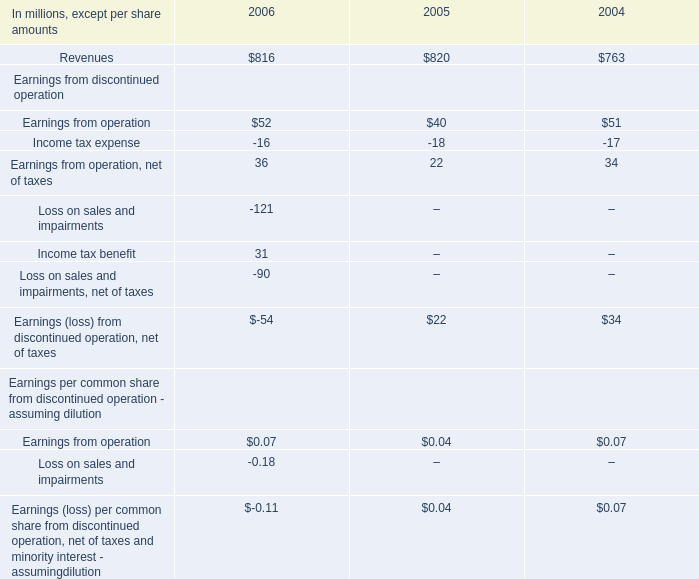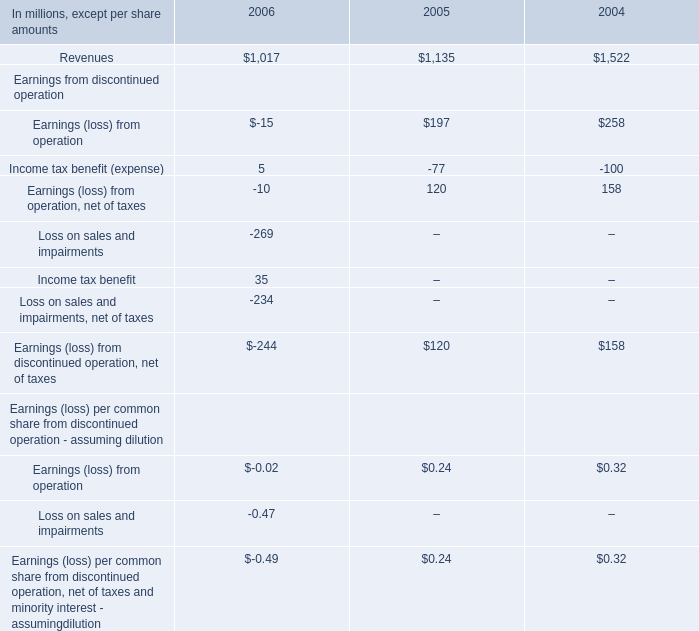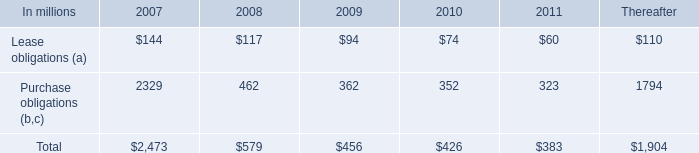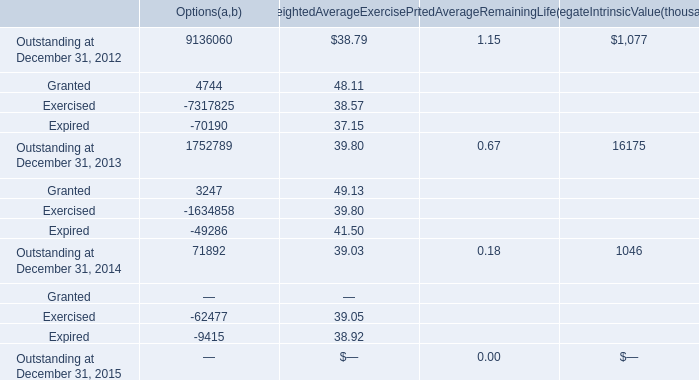what was the cumulative rent expense from 2004 to 2006 in millions 
Computations: (225 + (217 + 216))
Answer: 658.0. 